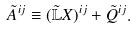Convert formula to latex. <formula><loc_0><loc_0><loc_500><loc_500>\tilde { A } ^ { i j } \equiv ( \tilde { \mathbb { L } } X ) ^ { i j } + \tilde { Q } ^ { i j } .</formula> 